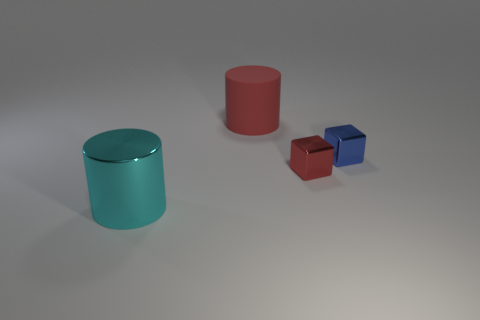Comparing the red and cyan object, which one is taller? The cyan object is taller than the red object. 